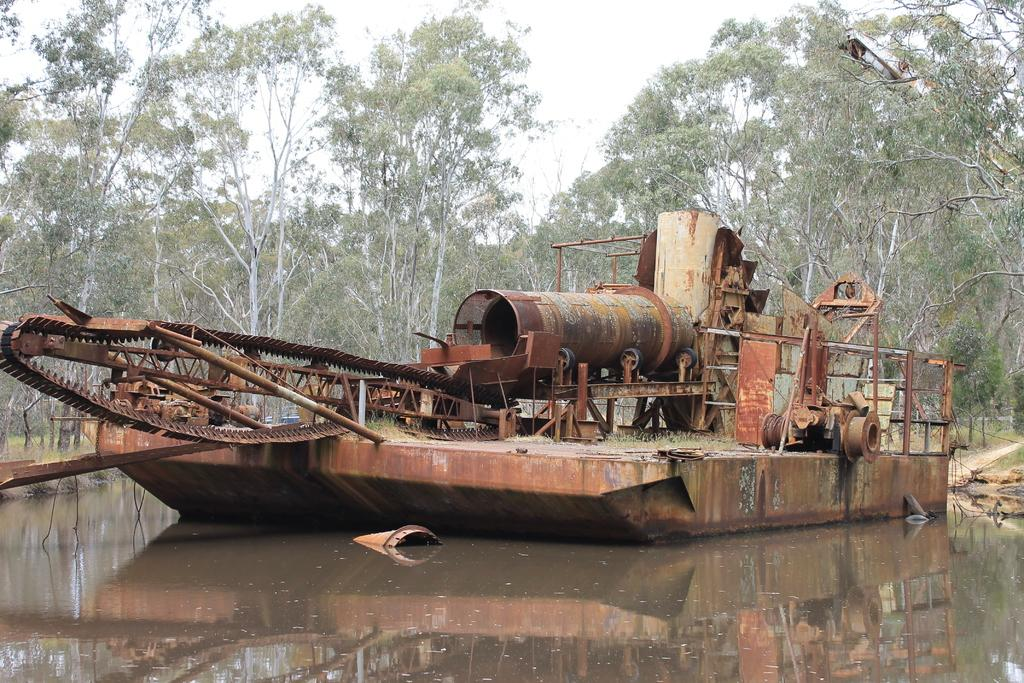What type of boat is in the image? There is a rusted iron boat in the image. Where is the boat located? The boat is on the water. What can be seen in the background of the image? There are trees with branches and leaves in the image. How many chickens are sitting on the plough in the image? There are no chickens or ploughs present in the image. 